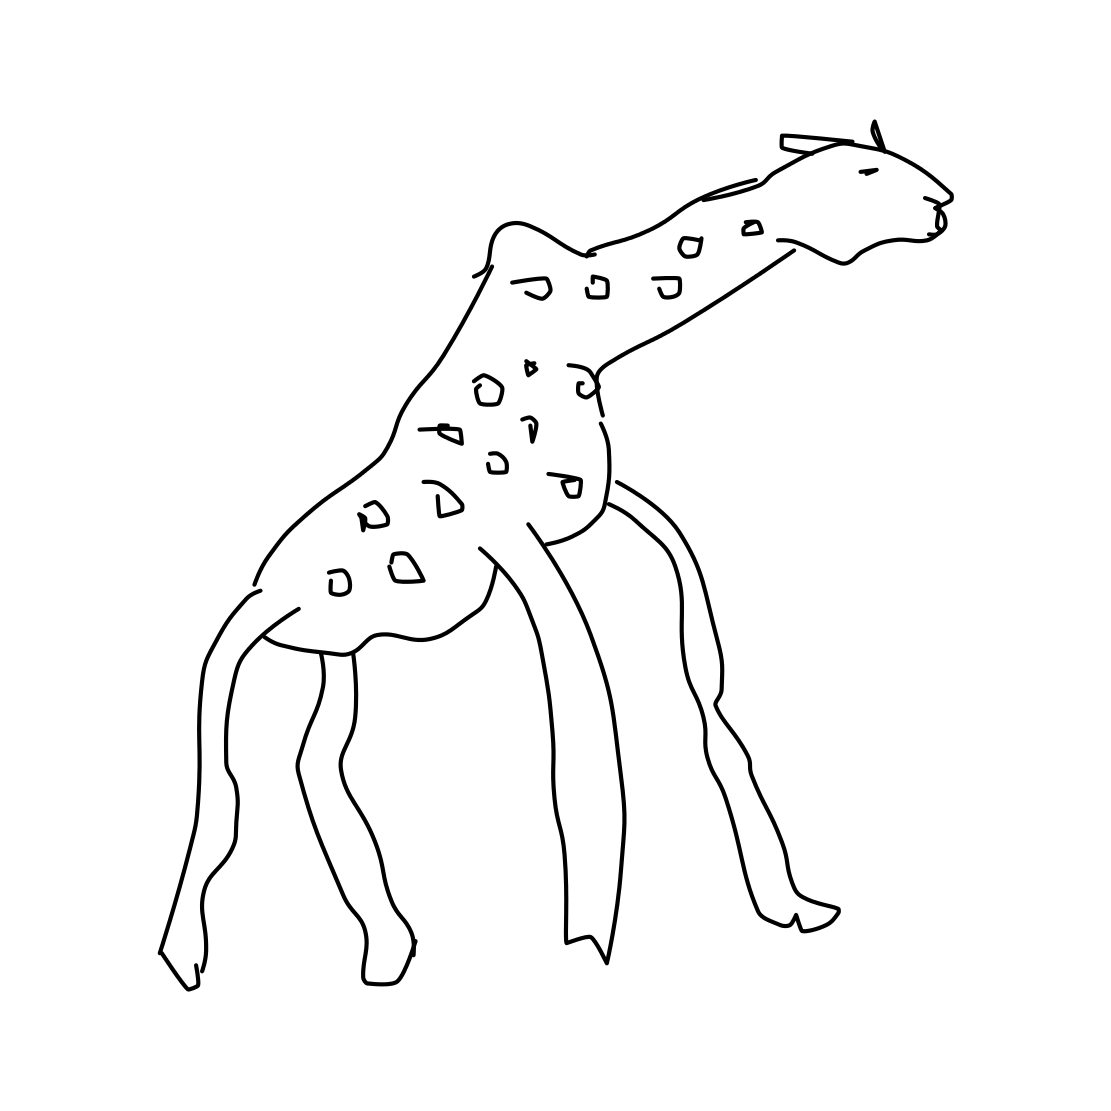In the scene, is a comb in it? There is no comb visible in the image; it's a simple line drawing of a giraffe. 